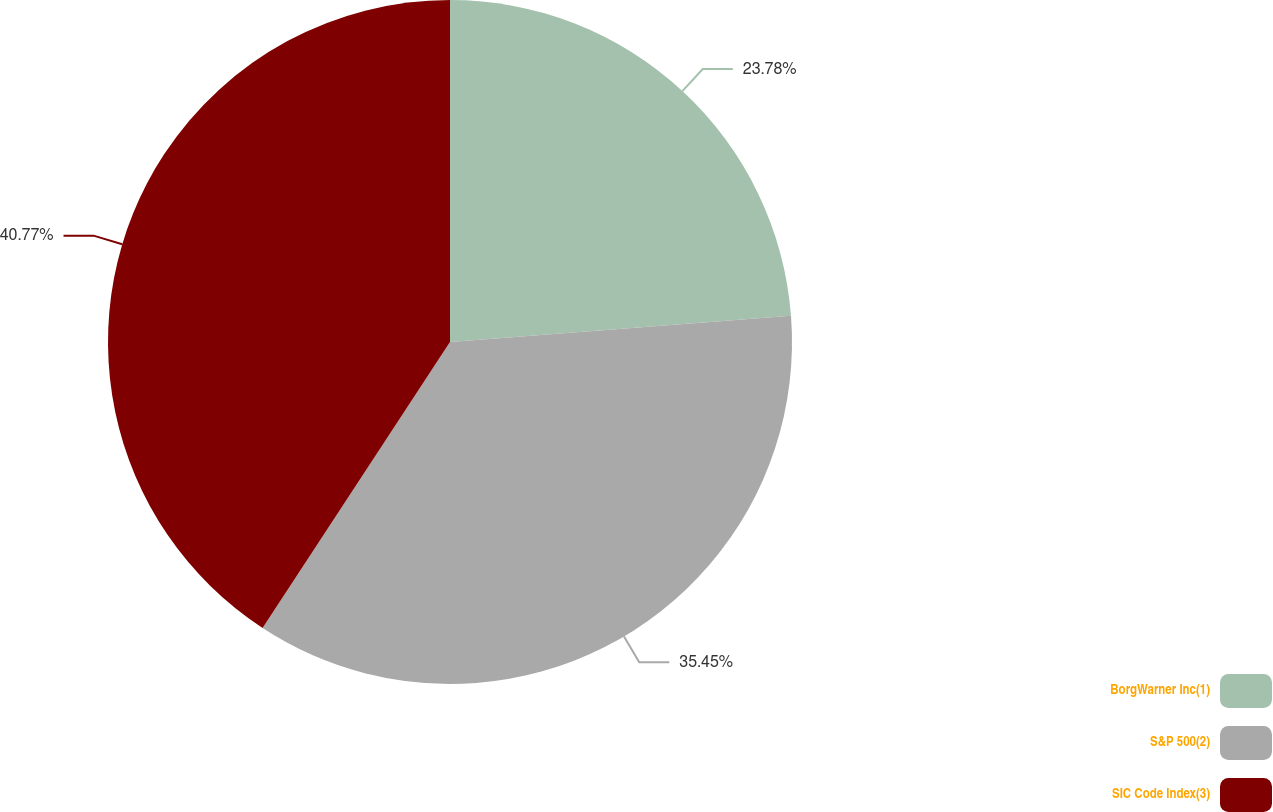Convert chart. <chart><loc_0><loc_0><loc_500><loc_500><pie_chart><fcel>BorgWarner Inc(1)<fcel>S&P 500(2)<fcel>SIC Code Index(3)<nl><fcel>23.78%<fcel>35.45%<fcel>40.77%<nl></chart> 